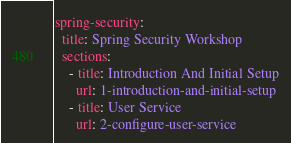<code> <loc_0><loc_0><loc_500><loc_500><_YAML_>spring-security:
  title: Spring Security Workshop
  sections:
    - title: Introduction And Initial Setup
      url: 1-introduction-and-initial-setup
    - title: User Service
      url: 2-configure-user-service</code> 